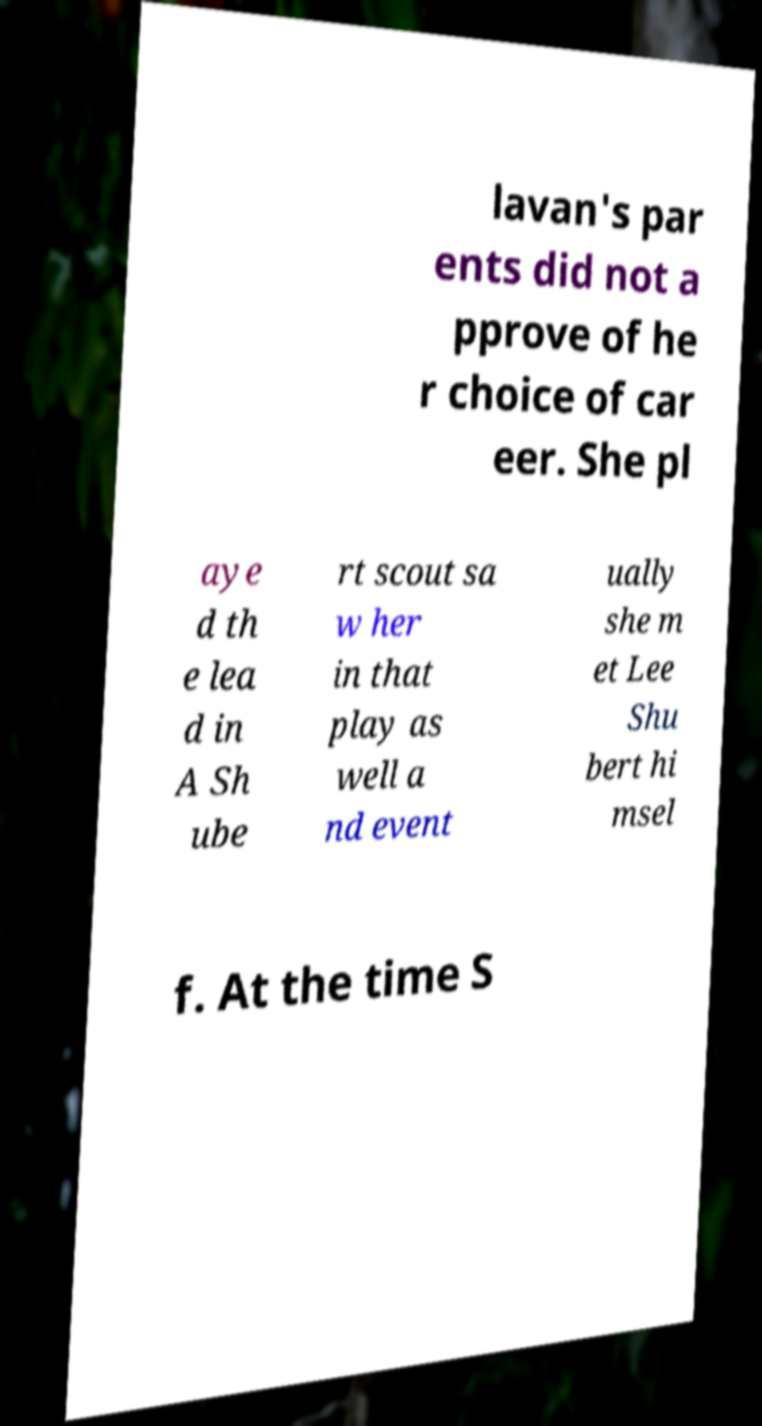Could you assist in decoding the text presented in this image and type it out clearly? lavan's par ents did not a pprove of he r choice of car eer. She pl aye d th e lea d in A Sh ube rt scout sa w her in that play as well a nd event ually she m et Lee Shu bert hi msel f. At the time S 